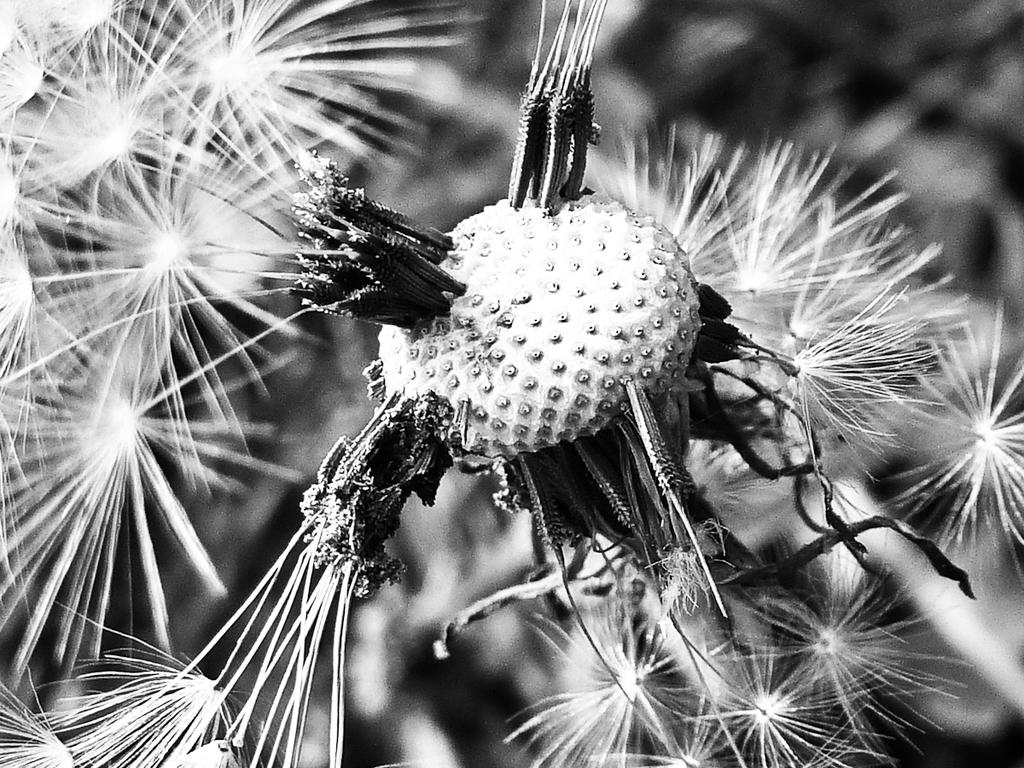What is the color scheme of the image? The image is black and white. What type of plant can be seen in the image? There are flowers of a plant in the image. How many pets are visible in the image? There are no pets present in the image. What type of brush is used to create the flowers in the image? The image is black and white, and there is no brush visible or implied in the creation of the flowers. 